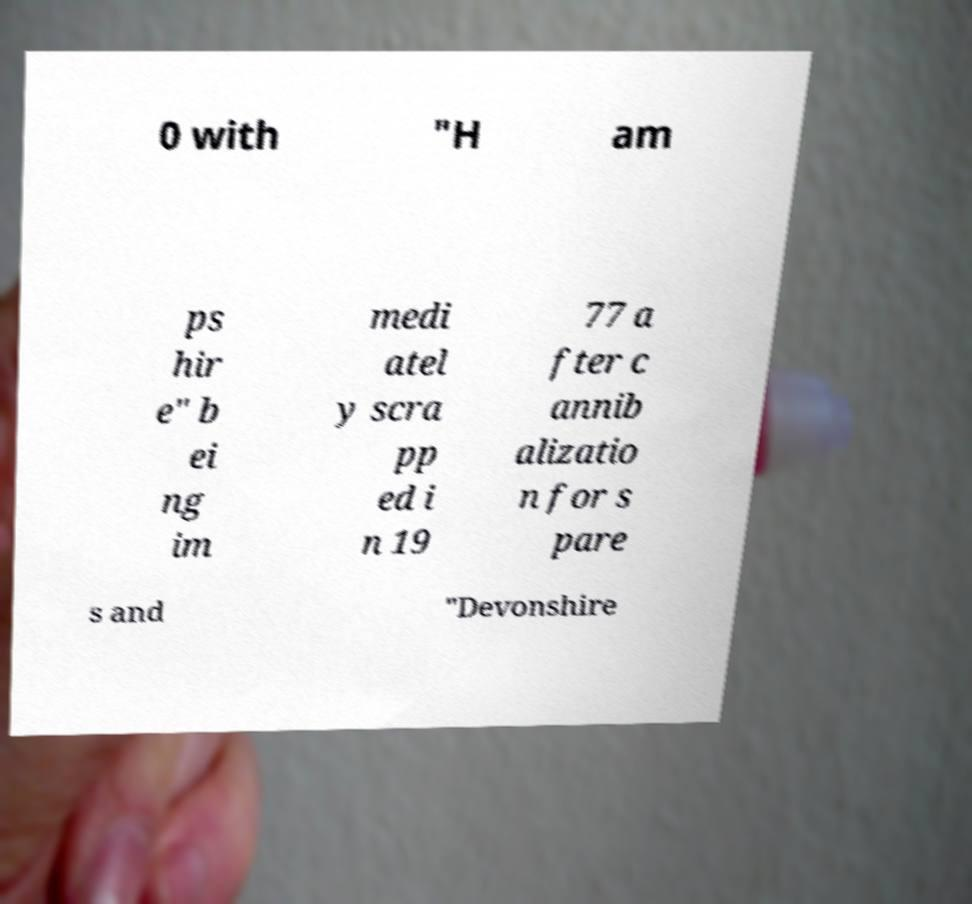There's text embedded in this image that I need extracted. Can you transcribe it verbatim? 0 with "H am ps hir e" b ei ng im medi atel y scra pp ed i n 19 77 a fter c annib alizatio n for s pare s and "Devonshire 